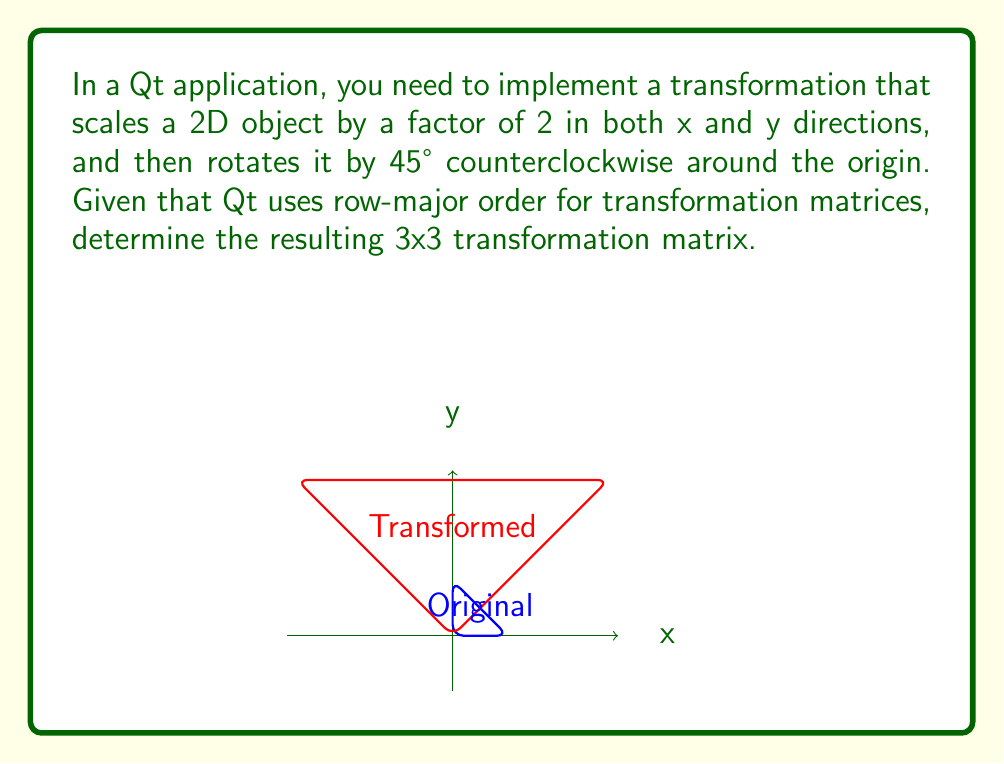Provide a solution to this math problem. Let's break this down step-by-step:

1) First, we need to create the scaling matrix. For a scale factor of 2 in both x and y directions, the scaling matrix is:

   $$S = \begin{bmatrix} 2 & 0 & 0 \\ 0 & 2 & 0 \\ 0 & 0 & 1 \end{bmatrix}$$

2) Next, we need the rotation matrix for 45° counterclockwise. The rotation matrix for an angle θ is:

   $$R = \begin{bmatrix} \cos θ & -\sin θ & 0 \\ \sin θ & \cos θ & 0 \\ 0 & 0 & 1 \end{bmatrix}$$

   For θ = 45°, we have $\cos 45° = \sin 45° = \frac{\sqrt{2}}{2}$. So our rotation matrix is:

   $$R = \begin{bmatrix} \frac{\sqrt{2}}{2} & -\frac{\sqrt{2}}{2} & 0 \\ \frac{\sqrt{2}}{2} & \frac{\sqrt{2}}{2} & 0 \\ 0 & 0 & 1 \end{bmatrix}$$

3) The final transformation matrix is the product of the rotation matrix and the scaling matrix: $T = R \cdot S$

4) Multiplying these matrices:

   $$T = \begin{bmatrix} \frac{\sqrt{2}}{2} & -\frac{\sqrt{2}}{2} & 0 \\ \frac{\sqrt{2}}{2} & \frac{\sqrt{2}}{2} & 0 \\ 0 & 0 & 1 \end{bmatrix} \cdot \begin{bmatrix} 2 & 0 & 0 \\ 0 & 2 & 0 \\ 0 & 0 & 1 \end{bmatrix}$$

   $$= \begin{bmatrix} \sqrt{2} & -\sqrt{2} & 0 \\ \sqrt{2} & \sqrt{2} & 0 \\ 0 & 0 & 1 \end{bmatrix}$$

5) Remember that Qt uses row-major order, so this matrix is already in the correct format for Qt.
Answer: $$\begin{bmatrix} \sqrt{2} & -\sqrt{2} & 0 \\ \sqrt{2} & \sqrt{2} & 0 \\ 0 & 0 & 1 \end{bmatrix}$$ 